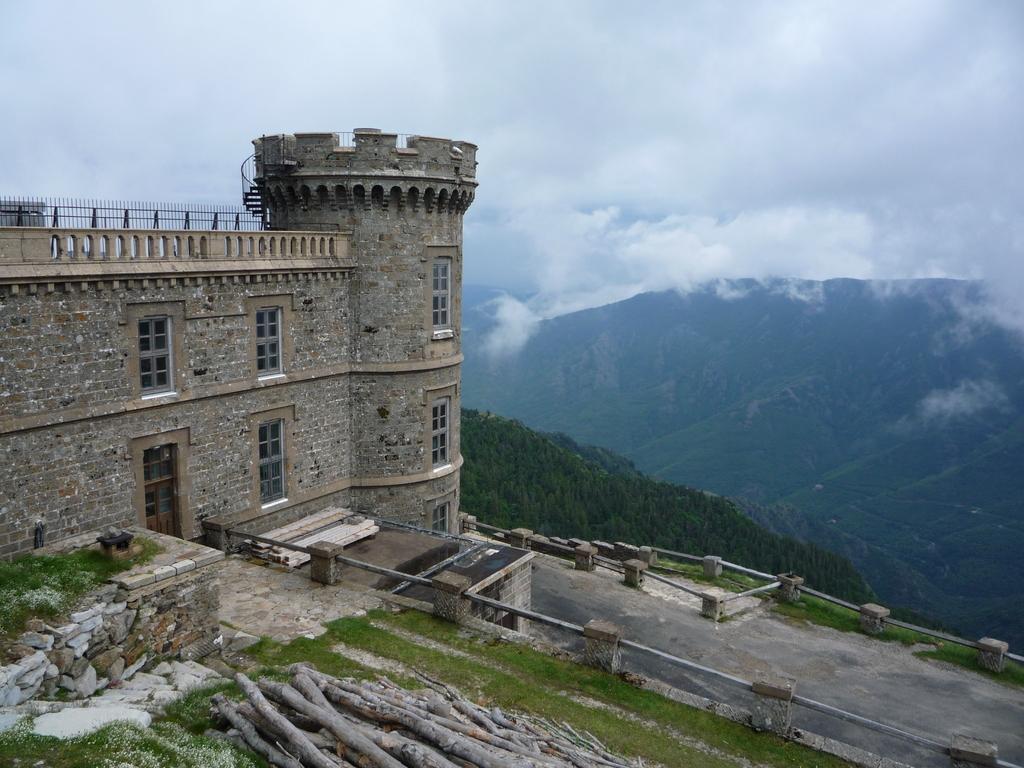Could you give a brief overview of what you see in this image? In this image we can see a building, there are some plants, wooden sticks, trees, fence and the mountains, also we can see the sky with clouds. 